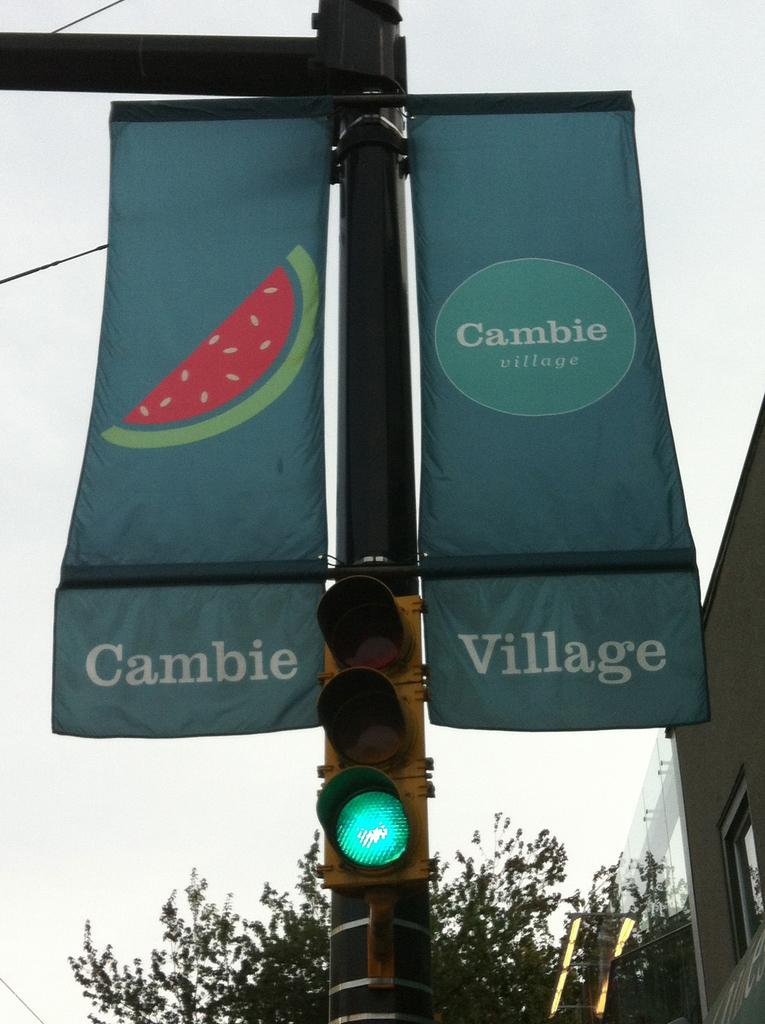<image>
Create a compact narrative representing the image presented. A Cambie Village banner is displayed on a pole with a stoplight 